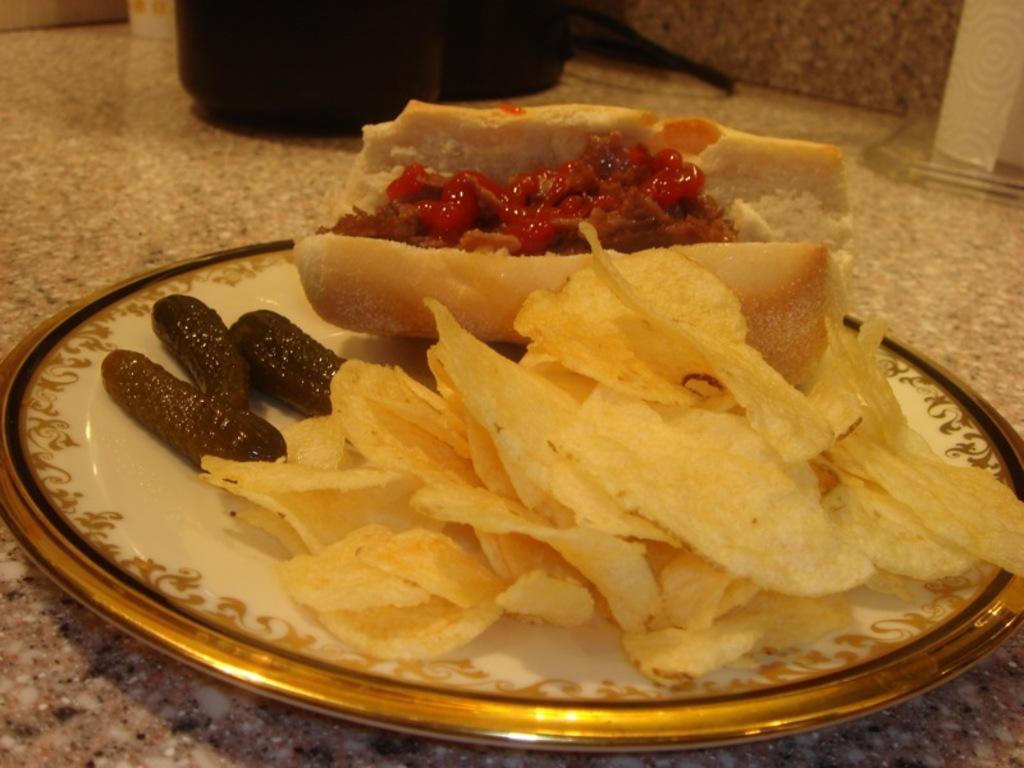Describe this image in one or two sentences. On a platform we can see a black object. We can see the food and chips placed on a plate. 